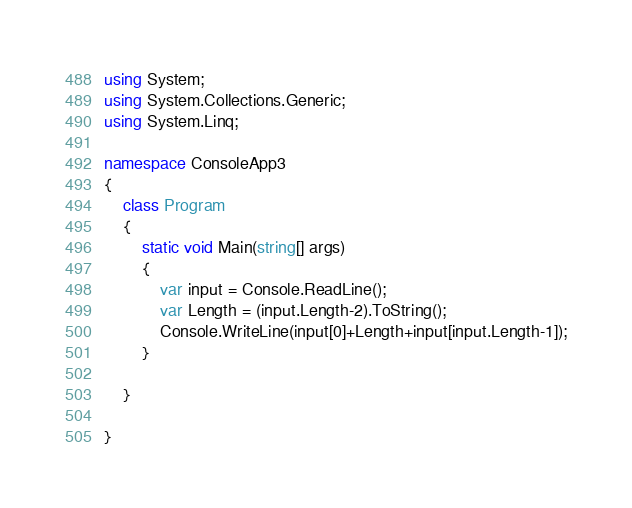<code> <loc_0><loc_0><loc_500><loc_500><_C#_>using System;
using System.Collections.Generic;
using System.Linq;

namespace ConsoleApp3
{
    class Program
    {
        static void Main(string[] args)
        {
            var input = Console.ReadLine();
            var Length = (input.Length-2).ToString();
            Console.WriteLine(input[0]+Length+input[input.Length-1]);
        }

    }

}

</code> 